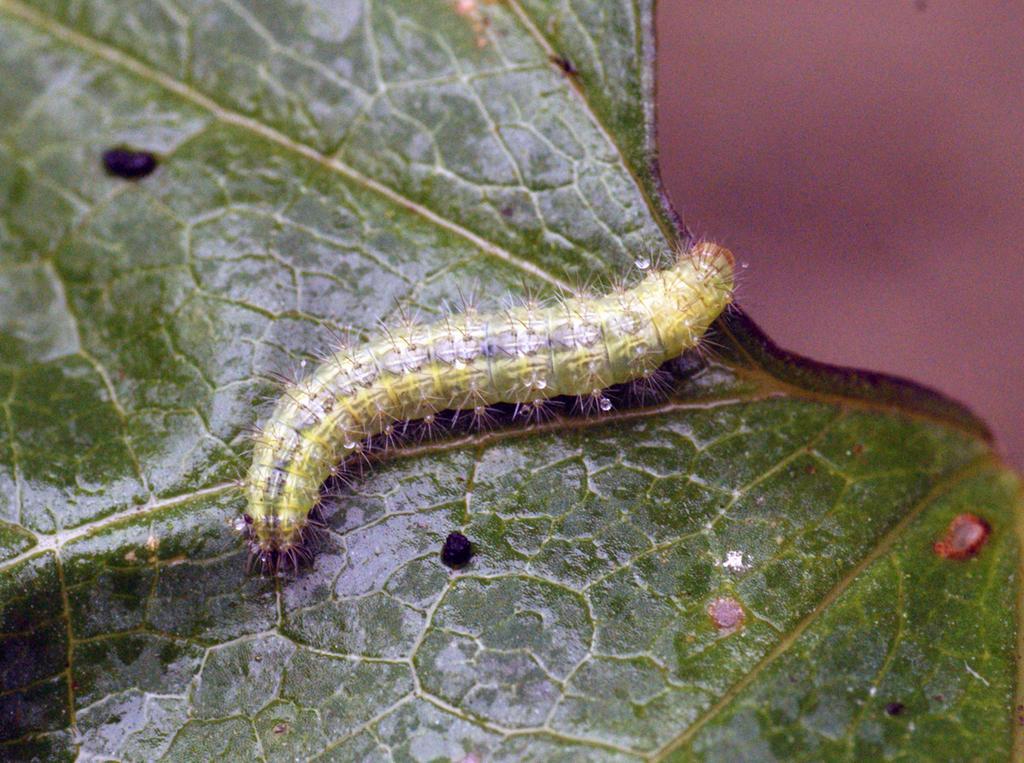Could you give a brief overview of what you see in this image? This picture shows a caterpillar on the leaf. 